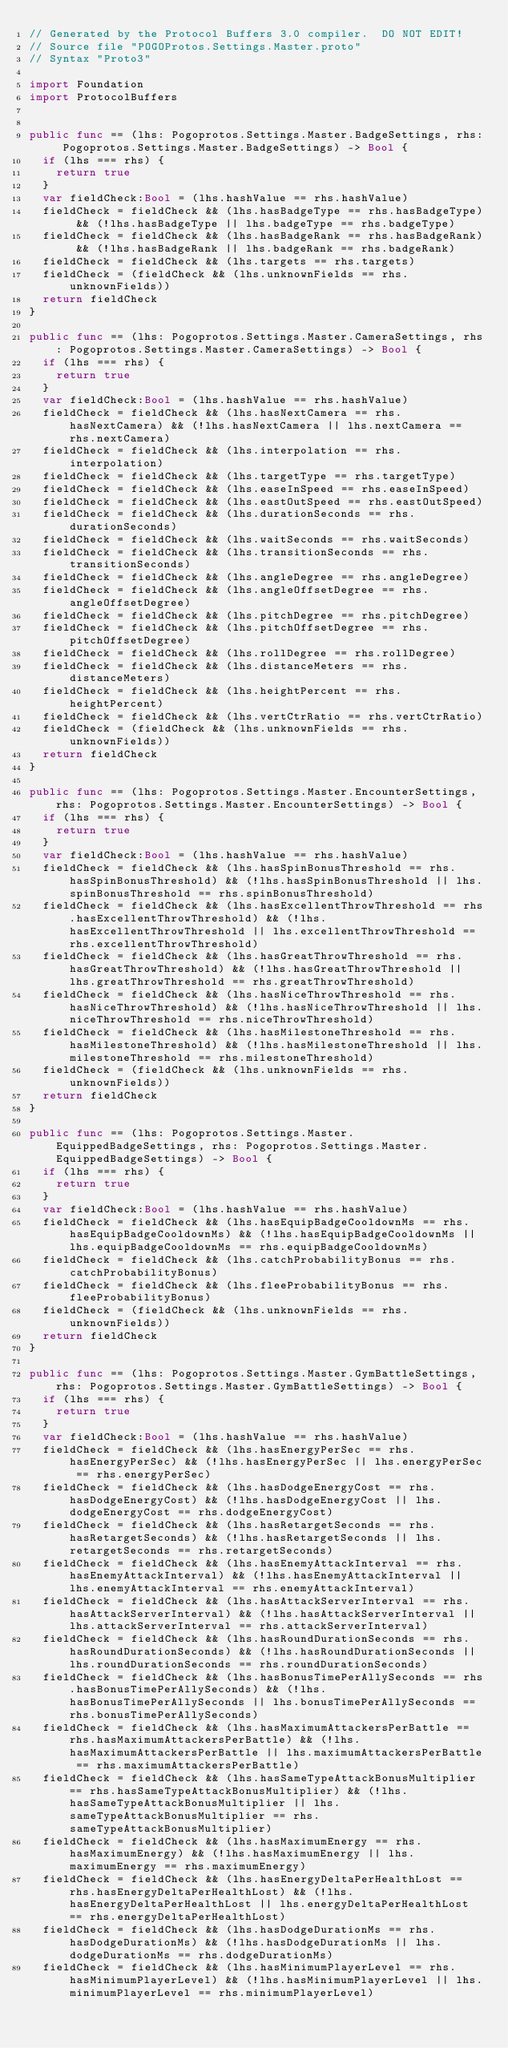Convert code to text. <code><loc_0><loc_0><loc_500><loc_500><_Swift_>// Generated by the Protocol Buffers 3.0 compiler.  DO NOT EDIT!
// Source file "POGOProtos.Settings.Master.proto"
// Syntax "Proto3"

import Foundation
import ProtocolBuffers


public func == (lhs: Pogoprotos.Settings.Master.BadgeSettings, rhs: Pogoprotos.Settings.Master.BadgeSettings) -> Bool {
  if (lhs === rhs) {
    return true
  }
  var fieldCheck:Bool = (lhs.hashValue == rhs.hashValue)
  fieldCheck = fieldCheck && (lhs.hasBadgeType == rhs.hasBadgeType) && (!lhs.hasBadgeType || lhs.badgeType == rhs.badgeType)
  fieldCheck = fieldCheck && (lhs.hasBadgeRank == rhs.hasBadgeRank) && (!lhs.hasBadgeRank || lhs.badgeRank == rhs.badgeRank)
  fieldCheck = fieldCheck && (lhs.targets == rhs.targets)
  fieldCheck = (fieldCheck && (lhs.unknownFields == rhs.unknownFields))
  return fieldCheck
}

public func == (lhs: Pogoprotos.Settings.Master.CameraSettings, rhs: Pogoprotos.Settings.Master.CameraSettings) -> Bool {
  if (lhs === rhs) {
    return true
  }
  var fieldCheck:Bool = (lhs.hashValue == rhs.hashValue)
  fieldCheck = fieldCheck && (lhs.hasNextCamera == rhs.hasNextCamera) && (!lhs.hasNextCamera || lhs.nextCamera == rhs.nextCamera)
  fieldCheck = fieldCheck && (lhs.interpolation == rhs.interpolation)
  fieldCheck = fieldCheck && (lhs.targetType == rhs.targetType)
  fieldCheck = fieldCheck && (lhs.easeInSpeed == rhs.easeInSpeed)
  fieldCheck = fieldCheck && (lhs.eastOutSpeed == rhs.eastOutSpeed)
  fieldCheck = fieldCheck && (lhs.durationSeconds == rhs.durationSeconds)
  fieldCheck = fieldCheck && (lhs.waitSeconds == rhs.waitSeconds)
  fieldCheck = fieldCheck && (lhs.transitionSeconds == rhs.transitionSeconds)
  fieldCheck = fieldCheck && (lhs.angleDegree == rhs.angleDegree)
  fieldCheck = fieldCheck && (lhs.angleOffsetDegree == rhs.angleOffsetDegree)
  fieldCheck = fieldCheck && (lhs.pitchDegree == rhs.pitchDegree)
  fieldCheck = fieldCheck && (lhs.pitchOffsetDegree == rhs.pitchOffsetDegree)
  fieldCheck = fieldCheck && (lhs.rollDegree == rhs.rollDegree)
  fieldCheck = fieldCheck && (lhs.distanceMeters == rhs.distanceMeters)
  fieldCheck = fieldCheck && (lhs.heightPercent == rhs.heightPercent)
  fieldCheck = fieldCheck && (lhs.vertCtrRatio == rhs.vertCtrRatio)
  fieldCheck = (fieldCheck && (lhs.unknownFields == rhs.unknownFields))
  return fieldCheck
}

public func == (lhs: Pogoprotos.Settings.Master.EncounterSettings, rhs: Pogoprotos.Settings.Master.EncounterSettings) -> Bool {
  if (lhs === rhs) {
    return true
  }
  var fieldCheck:Bool = (lhs.hashValue == rhs.hashValue)
  fieldCheck = fieldCheck && (lhs.hasSpinBonusThreshold == rhs.hasSpinBonusThreshold) && (!lhs.hasSpinBonusThreshold || lhs.spinBonusThreshold == rhs.spinBonusThreshold)
  fieldCheck = fieldCheck && (lhs.hasExcellentThrowThreshold == rhs.hasExcellentThrowThreshold) && (!lhs.hasExcellentThrowThreshold || lhs.excellentThrowThreshold == rhs.excellentThrowThreshold)
  fieldCheck = fieldCheck && (lhs.hasGreatThrowThreshold == rhs.hasGreatThrowThreshold) && (!lhs.hasGreatThrowThreshold || lhs.greatThrowThreshold == rhs.greatThrowThreshold)
  fieldCheck = fieldCheck && (lhs.hasNiceThrowThreshold == rhs.hasNiceThrowThreshold) && (!lhs.hasNiceThrowThreshold || lhs.niceThrowThreshold == rhs.niceThrowThreshold)
  fieldCheck = fieldCheck && (lhs.hasMilestoneThreshold == rhs.hasMilestoneThreshold) && (!lhs.hasMilestoneThreshold || lhs.milestoneThreshold == rhs.milestoneThreshold)
  fieldCheck = (fieldCheck && (lhs.unknownFields == rhs.unknownFields))
  return fieldCheck
}

public func == (lhs: Pogoprotos.Settings.Master.EquippedBadgeSettings, rhs: Pogoprotos.Settings.Master.EquippedBadgeSettings) -> Bool {
  if (lhs === rhs) {
    return true
  }
  var fieldCheck:Bool = (lhs.hashValue == rhs.hashValue)
  fieldCheck = fieldCheck && (lhs.hasEquipBadgeCooldownMs == rhs.hasEquipBadgeCooldownMs) && (!lhs.hasEquipBadgeCooldownMs || lhs.equipBadgeCooldownMs == rhs.equipBadgeCooldownMs)
  fieldCheck = fieldCheck && (lhs.catchProbabilityBonus == rhs.catchProbabilityBonus)
  fieldCheck = fieldCheck && (lhs.fleeProbabilityBonus == rhs.fleeProbabilityBonus)
  fieldCheck = (fieldCheck && (lhs.unknownFields == rhs.unknownFields))
  return fieldCheck
}

public func == (lhs: Pogoprotos.Settings.Master.GymBattleSettings, rhs: Pogoprotos.Settings.Master.GymBattleSettings) -> Bool {
  if (lhs === rhs) {
    return true
  }
  var fieldCheck:Bool = (lhs.hashValue == rhs.hashValue)
  fieldCheck = fieldCheck && (lhs.hasEnergyPerSec == rhs.hasEnergyPerSec) && (!lhs.hasEnergyPerSec || lhs.energyPerSec == rhs.energyPerSec)
  fieldCheck = fieldCheck && (lhs.hasDodgeEnergyCost == rhs.hasDodgeEnergyCost) && (!lhs.hasDodgeEnergyCost || lhs.dodgeEnergyCost == rhs.dodgeEnergyCost)
  fieldCheck = fieldCheck && (lhs.hasRetargetSeconds == rhs.hasRetargetSeconds) && (!lhs.hasRetargetSeconds || lhs.retargetSeconds == rhs.retargetSeconds)
  fieldCheck = fieldCheck && (lhs.hasEnemyAttackInterval == rhs.hasEnemyAttackInterval) && (!lhs.hasEnemyAttackInterval || lhs.enemyAttackInterval == rhs.enemyAttackInterval)
  fieldCheck = fieldCheck && (lhs.hasAttackServerInterval == rhs.hasAttackServerInterval) && (!lhs.hasAttackServerInterval || lhs.attackServerInterval == rhs.attackServerInterval)
  fieldCheck = fieldCheck && (lhs.hasRoundDurationSeconds == rhs.hasRoundDurationSeconds) && (!lhs.hasRoundDurationSeconds || lhs.roundDurationSeconds == rhs.roundDurationSeconds)
  fieldCheck = fieldCheck && (lhs.hasBonusTimePerAllySeconds == rhs.hasBonusTimePerAllySeconds) && (!lhs.hasBonusTimePerAllySeconds || lhs.bonusTimePerAllySeconds == rhs.bonusTimePerAllySeconds)
  fieldCheck = fieldCheck && (lhs.hasMaximumAttackersPerBattle == rhs.hasMaximumAttackersPerBattle) && (!lhs.hasMaximumAttackersPerBattle || lhs.maximumAttackersPerBattle == rhs.maximumAttackersPerBattle)
  fieldCheck = fieldCheck && (lhs.hasSameTypeAttackBonusMultiplier == rhs.hasSameTypeAttackBonusMultiplier) && (!lhs.hasSameTypeAttackBonusMultiplier || lhs.sameTypeAttackBonusMultiplier == rhs.sameTypeAttackBonusMultiplier)
  fieldCheck = fieldCheck && (lhs.hasMaximumEnergy == rhs.hasMaximumEnergy) && (!lhs.hasMaximumEnergy || lhs.maximumEnergy == rhs.maximumEnergy)
  fieldCheck = fieldCheck && (lhs.hasEnergyDeltaPerHealthLost == rhs.hasEnergyDeltaPerHealthLost) && (!lhs.hasEnergyDeltaPerHealthLost || lhs.energyDeltaPerHealthLost == rhs.energyDeltaPerHealthLost)
  fieldCheck = fieldCheck && (lhs.hasDodgeDurationMs == rhs.hasDodgeDurationMs) && (!lhs.hasDodgeDurationMs || lhs.dodgeDurationMs == rhs.dodgeDurationMs)
  fieldCheck = fieldCheck && (lhs.hasMinimumPlayerLevel == rhs.hasMinimumPlayerLevel) && (!lhs.hasMinimumPlayerLevel || lhs.minimumPlayerLevel == rhs.minimumPlayerLevel)</code> 